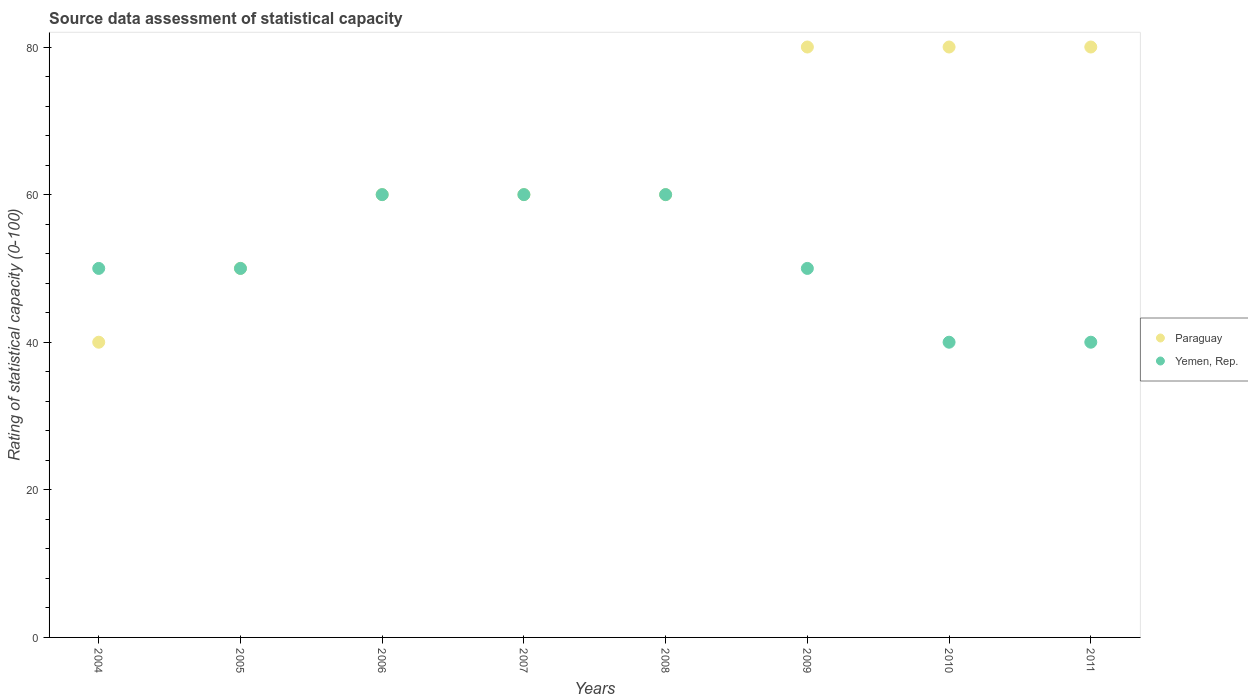How many different coloured dotlines are there?
Keep it short and to the point. 2. Is the number of dotlines equal to the number of legend labels?
Your answer should be very brief. Yes. What is the rating of statistical capacity in Paraguay in 2007?
Your answer should be compact. 60. Across all years, what is the maximum rating of statistical capacity in Paraguay?
Make the answer very short. 80. Across all years, what is the minimum rating of statistical capacity in Yemen, Rep.?
Offer a very short reply. 40. In which year was the rating of statistical capacity in Paraguay minimum?
Your answer should be compact. 2004. What is the total rating of statistical capacity in Paraguay in the graph?
Provide a succinct answer. 510. What is the difference between the rating of statistical capacity in Yemen, Rep. in 2004 and that in 2011?
Provide a succinct answer. 10. What is the difference between the rating of statistical capacity in Paraguay in 2006 and the rating of statistical capacity in Yemen, Rep. in 2005?
Your response must be concise. 10. What is the average rating of statistical capacity in Paraguay per year?
Offer a very short reply. 63.75. In the year 2006, what is the difference between the rating of statistical capacity in Paraguay and rating of statistical capacity in Yemen, Rep.?
Provide a short and direct response. 0. In how many years, is the rating of statistical capacity in Paraguay greater than 76?
Your response must be concise. 3. Is the rating of statistical capacity in Paraguay in 2006 less than that in 2010?
Give a very brief answer. Yes. Is the difference between the rating of statistical capacity in Paraguay in 2005 and 2009 greater than the difference between the rating of statistical capacity in Yemen, Rep. in 2005 and 2009?
Your answer should be compact. No. What is the difference between the highest and the lowest rating of statistical capacity in Yemen, Rep.?
Your answer should be compact. 20. Is the rating of statistical capacity in Paraguay strictly greater than the rating of statistical capacity in Yemen, Rep. over the years?
Offer a terse response. No. Is the rating of statistical capacity in Paraguay strictly less than the rating of statistical capacity in Yemen, Rep. over the years?
Keep it short and to the point. No. Are the values on the major ticks of Y-axis written in scientific E-notation?
Give a very brief answer. No. Does the graph contain any zero values?
Keep it short and to the point. No. How many legend labels are there?
Offer a very short reply. 2. How are the legend labels stacked?
Offer a terse response. Vertical. What is the title of the graph?
Provide a succinct answer. Source data assessment of statistical capacity. Does "Latin America(all income levels)" appear as one of the legend labels in the graph?
Your answer should be very brief. No. What is the label or title of the X-axis?
Make the answer very short. Years. What is the label or title of the Y-axis?
Offer a terse response. Rating of statistical capacity (0-100). What is the Rating of statistical capacity (0-100) in Paraguay in 2004?
Provide a short and direct response. 40. What is the Rating of statistical capacity (0-100) in Yemen, Rep. in 2004?
Make the answer very short. 50. What is the Rating of statistical capacity (0-100) in Paraguay in 2005?
Your response must be concise. 50. What is the Rating of statistical capacity (0-100) in Yemen, Rep. in 2005?
Provide a short and direct response. 50. What is the Rating of statistical capacity (0-100) in Paraguay in 2006?
Your answer should be compact. 60. What is the Rating of statistical capacity (0-100) in Paraguay in 2007?
Give a very brief answer. 60. What is the Rating of statistical capacity (0-100) in Paraguay in 2008?
Provide a succinct answer. 60. What is the Rating of statistical capacity (0-100) in Yemen, Rep. in 2009?
Your answer should be compact. 50. What is the Rating of statistical capacity (0-100) in Paraguay in 2010?
Provide a succinct answer. 80. What is the Rating of statistical capacity (0-100) in Yemen, Rep. in 2010?
Provide a succinct answer. 40. What is the Rating of statistical capacity (0-100) of Paraguay in 2011?
Your answer should be compact. 80. Across all years, what is the maximum Rating of statistical capacity (0-100) of Yemen, Rep.?
Ensure brevity in your answer.  60. Across all years, what is the minimum Rating of statistical capacity (0-100) of Paraguay?
Provide a short and direct response. 40. Across all years, what is the minimum Rating of statistical capacity (0-100) of Yemen, Rep.?
Your answer should be very brief. 40. What is the total Rating of statistical capacity (0-100) of Paraguay in the graph?
Provide a succinct answer. 510. What is the total Rating of statistical capacity (0-100) of Yemen, Rep. in the graph?
Your answer should be very brief. 410. What is the difference between the Rating of statistical capacity (0-100) of Paraguay in 2004 and that in 2005?
Your response must be concise. -10. What is the difference between the Rating of statistical capacity (0-100) in Yemen, Rep. in 2004 and that in 2005?
Your answer should be very brief. 0. What is the difference between the Rating of statistical capacity (0-100) of Paraguay in 2004 and that in 2006?
Ensure brevity in your answer.  -20. What is the difference between the Rating of statistical capacity (0-100) of Yemen, Rep. in 2004 and that in 2006?
Make the answer very short. -10. What is the difference between the Rating of statistical capacity (0-100) of Paraguay in 2004 and that in 2007?
Your answer should be very brief. -20. What is the difference between the Rating of statistical capacity (0-100) in Yemen, Rep. in 2004 and that in 2007?
Give a very brief answer. -10. What is the difference between the Rating of statistical capacity (0-100) of Paraguay in 2004 and that in 2009?
Make the answer very short. -40. What is the difference between the Rating of statistical capacity (0-100) in Yemen, Rep. in 2004 and that in 2011?
Provide a succinct answer. 10. What is the difference between the Rating of statistical capacity (0-100) in Paraguay in 2005 and that in 2006?
Your answer should be compact. -10. What is the difference between the Rating of statistical capacity (0-100) of Yemen, Rep. in 2005 and that in 2006?
Provide a short and direct response. -10. What is the difference between the Rating of statistical capacity (0-100) in Paraguay in 2005 and that in 2007?
Keep it short and to the point. -10. What is the difference between the Rating of statistical capacity (0-100) of Paraguay in 2005 and that in 2008?
Make the answer very short. -10. What is the difference between the Rating of statistical capacity (0-100) of Yemen, Rep. in 2005 and that in 2008?
Offer a very short reply. -10. What is the difference between the Rating of statistical capacity (0-100) of Paraguay in 2005 and that in 2009?
Keep it short and to the point. -30. What is the difference between the Rating of statistical capacity (0-100) of Yemen, Rep. in 2005 and that in 2009?
Keep it short and to the point. 0. What is the difference between the Rating of statistical capacity (0-100) of Paraguay in 2005 and that in 2011?
Provide a short and direct response. -30. What is the difference between the Rating of statistical capacity (0-100) in Yemen, Rep. in 2006 and that in 2007?
Offer a very short reply. 0. What is the difference between the Rating of statistical capacity (0-100) in Yemen, Rep. in 2006 and that in 2008?
Offer a very short reply. 0. What is the difference between the Rating of statistical capacity (0-100) of Yemen, Rep. in 2007 and that in 2008?
Offer a very short reply. 0. What is the difference between the Rating of statistical capacity (0-100) of Paraguay in 2008 and that in 2009?
Offer a very short reply. -20. What is the difference between the Rating of statistical capacity (0-100) of Paraguay in 2008 and that in 2010?
Your answer should be compact. -20. What is the difference between the Rating of statistical capacity (0-100) of Paraguay in 2008 and that in 2011?
Make the answer very short. -20. What is the difference between the Rating of statistical capacity (0-100) in Yemen, Rep. in 2008 and that in 2011?
Provide a succinct answer. 20. What is the difference between the Rating of statistical capacity (0-100) of Paraguay in 2009 and that in 2010?
Make the answer very short. 0. What is the difference between the Rating of statistical capacity (0-100) of Paraguay in 2009 and that in 2011?
Provide a short and direct response. 0. What is the difference between the Rating of statistical capacity (0-100) in Yemen, Rep. in 2009 and that in 2011?
Your response must be concise. 10. What is the difference between the Rating of statistical capacity (0-100) of Paraguay in 2004 and the Rating of statistical capacity (0-100) of Yemen, Rep. in 2005?
Your response must be concise. -10. What is the difference between the Rating of statistical capacity (0-100) in Paraguay in 2004 and the Rating of statistical capacity (0-100) in Yemen, Rep. in 2006?
Keep it short and to the point. -20. What is the difference between the Rating of statistical capacity (0-100) in Paraguay in 2004 and the Rating of statistical capacity (0-100) in Yemen, Rep. in 2008?
Give a very brief answer. -20. What is the difference between the Rating of statistical capacity (0-100) in Paraguay in 2004 and the Rating of statistical capacity (0-100) in Yemen, Rep. in 2009?
Your answer should be very brief. -10. What is the difference between the Rating of statistical capacity (0-100) in Paraguay in 2005 and the Rating of statistical capacity (0-100) in Yemen, Rep. in 2007?
Offer a very short reply. -10. What is the difference between the Rating of statistical capacity (0-100) in Paraguay in 2005 and the Rating of statistical capacity (0-100) in Yemen, Rep. in 2008?
Your answer should be compact. -10. What is the difference between the Rating of statistical capacity (0-100) of Paraguay in 2005 and the Rating of statistical capacity (0-100) of Yemen, Rep. in 2010?
Offer a very short reply. 10. What is the difference between the Rating of statistical capacity (0-100) of Paraguay in 2006 and the Rating of statistical capacity (0-100) of Yemen, Rep. in 2007?
Make the answer very short. 0. What is the difference between the Rating of statistical capacity (0-100) in Paraguay in 2006 and the Rating of statistical capacity (0-100) in Yemen, Rep. in 2008?
Give a very brief answer. 0. What is the difference between the Rating of statistical capacity (0-100) in Paraguay in 2006 and the Rating of statistical capacity (0-100) in Yemen, Rep. in 2009?
Your answer should be compact. 10. What is the difference between the Rating of statistical capacity (0-100) in Paraguay in 2006 and the Rating of statistical capacity (0-100) in Yemen, Rep. in 2010?
Your answer should be very brief. 20. What is the difference between the Rating of statistical capacity (0-100) in Paraguay in 2007 and the Rating of statistical capacity (0-100) in Yemen, Rep. in 2010?
Make the answer very short. 20. What is the difference between the Rating of statistical capacity (0-100) in Paraguay in 2007 and the Rating of statistical capacity (0-100) in Yemen, Rep. in 2011?
Your answer should be very brief. 20. What is the difference between the Rating of statistical capacity (0-100) of Paraguay in 2008 and the Rating of statistical capacity (0-100) of Yemen, Rep. in 2009?
Your answer should be very brief. 10. What is the difference between the Rating of statistical capacity (0-100) in Paraguay in 2008 and the Rating of statistical capacity (0-100) in Yemen, Rep. in 2010?
Your response must be concise. 20. What is the difference between the Rating of statistical capacity (0-100) in Paraguay in 2009 and the Rating of statistical capacity (0-100) in Yemen, Rep. in 2010?
Give a very brief answer. 40. What is the difference between the Rating of statistical capacity (0-100) in Paraguay in 2010 and the Rating of statistical capacity (0-100) in Yemen, Rep. in 2011?
Offer a terse response. 40. What is the average Rating of statistical capacity (0-100) in Paraguay per year?
Offer a very short reply. 63.75. What is the average Rating of statistical capacity (0-100) in Yemen, Rep. per year?
Offer a very short reply. 51.25. In the year 2005, what is the difference between the Rating of statistical capacity (0-100) of Paraguay and Rating of statistical capacity (0-100) of Yemen, Rep.?
Your answer should be very brief. 0. In the year 2009, what is the difference between the Rating of statistical capacity (0-100) in Paraguay and Rating of statistical capacity (0-100) in Yemen, Rep.?
Make the answer very short. 30. In the year 2010, what is the difference between the Rating of statistical capacity (0-100) in Paraguay and Rating of statistical capacity (0-100) in Yemen, Rep.?
Provide a short and direct response. 40. In the year 2011, what is the difference between the Rating of statistical capacity (0-100) in Paraguay and Rating of statistical capacity (0-100) in Yemen, Rep.?
Ensure brevity in your answer.  40. What is the ratio of the Rating of statistical capacity (0-100) of Paraguay in 2004 to that in 2005?
Your answer should be very brief. 0.8. What is the ratio of the Rating of statistical capacity (0-100) in Yemen, Rep. in 2004 to that in 2005?
Your answer should be compact. 1. What is the ratio of the Rating of statistical capacity (0-100) of Yemen, Rep. in 2004 to that in 2006?
Provide a short and direct response. 0.83. What is the ratio of the Rating of statistical capacity (0-100) in Yemen, Rep. in 2004 to that in 2007?
Your answer should be compact. 0.83. What is the ratio of the Rating of statistical capacity (0-100) in Paraguay in 2004 to that in 2008?
Provide a succinct answer. 0.67. What is the ratio of the Rating of statistical capacity (0-100) in Yemen, Rep. in 2004 to that in 2008?
Your answer should be compact. 0.83. What is the ratio of the Rating of statistical capacity (0-100) in Paraguay in 2004 to that in 2010?
Your response must be concise. 0.5. What is the ratio of the Rating of statistical capacity (0-100) of Yemen, Rep. in 2004 to that in 2010?
Your answer should be compact. 1.25. What is the ratio of the Rating of statistical capacity (0-100) in Paraguay in 2004 to that in 2011?
Offer a terse response. 0.5. What is the ratio of the Rating of statistical capacity (0-100) of Yemen, Rep. in 2004 to that in 2011?
Provide a short and direct response. 1.25. What is the ratio of the Rating of statistical capacity (0-100) in Paraguay in 2005 to that in 2007?
Your response must be concise. 0.83. What is the ratio of the Rating of statistical capacity (0-100) in Yemen, Rep. in 2005 to that in 2007?
Your answer should be very brief. 0.83. What is the ratio of the Rating of statistical capacity (0-100) of Paraguay in 2005 to that in 2008?
Keep it short and to the point. 0.83. What is the ratio of the Rating of statistical capacity (0-100) in Yemen, Rep. in 2005 to that in 2009?
Your answer should be very brief. 1. What is the ratio of the Rating of statistical capacity (0-100) of Paraguay in 2005 to that in 2010?
Your response must be concise. 0.62. What is the ratio of the Rating of statistical capacity (0-100) in Yemen, Rep. in 2005 to that in 2010?
Your response must be concise. 1.25. What is the ratio of the Rating of statistical capacity (0-100) of Paraguay in 2005 to that in 2011?
Keep it short and to the point. 0.62. What is the ratio of the Rating of statistical capacity (0-100) of Yemen, Rep. in 2005 to that in 2011?
Your response must be concise. 1.25. What is the ratio of the Rating of statistical capacity (0-100) in Paraguay in 2006 to that in 2008?
Your answer should be very brief. 1. What is the ratio of the Rating of statistical capacity (0-100) in Yemen, Rep. in 2006 to that in 2008?
Provide a short and direct response. 1. What is the ratio of the Rating of statistical capacity (0-100) in Yemen, Rep. in 2006 to that in 2009?
Offer a terse response. 1.2. What is the ratio of the Rating of statistical capacity (0-100) in Paraguay in 2007 to that in 2008?
Keep it short and to the point. 1. What is the ratio of the Rating of statistical capacity (0-100) of Yemen, Rep. in 2007 to that in 2008?
Your answer should be compact. 1. What is the ratio of the Rating of statistical capacity (0-100) in Paraguay in 2007 to that in 2009?
Provide a succinct answer. 0.75. What is the ratio of the Rating of statistical capacity (0-100) in Yemen, Rep. in 2007 to that in 2010?
Keep it short and to the point. 1.5. What is the ratio of the Rating of statistical capacity (0-100) in Paraguay in 2008 to that in 2009?
Offer a terse response. 0.75. What is the ratio of the Rating of statistical capacity (0-100) in Paraguay in 2008 to that in 2010?
Offer a terse response. 0.75. What is the ratio of the Rating of statistical capacity (0-100) of Yemen, Rep. in 2008 to that in 2010?
Make the answer very short. 1.5. What is the ratio of the Rating of statistical capacity (0-100) in Paraguay in 2008 to that in 2011?
Offer a very short reply. 0.75. What is the ratio of the Rating of statistical capacity (0-100) in Yemen, Rep. in 2008 to that in 2011?
Your response must be concise. 1.5. What is the ratio of the Rating of statistical capacity (0-100) of Paraguay in 2009 to that in 2010?
Provide a succinct answer. 1. What is the ratio of the Rating of statistical capacity (0-100) in Paraguay in 2009 to that in 2011?
Provide a short and direct response. 1. What is the ratio of the Rating of statistical capacity (0-100) in Yemen, Rep. in 2009 to that in 2011?
Your answer should be very brief. 1.25. What is the ratio of the Rating of statistical capacity (0-100) of Paraguay in 2010 to that in 2011?
Provide a succinct answer. 1. What is the difference between the highest and the second highest Rating of statistical capacity (0-100) of Yemen, Rep.?
Your answer should be very brief. 0. 